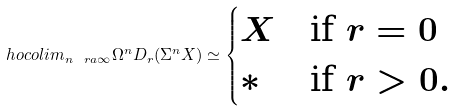Convert formula to latex. <formula><loc_0><loc_0><loc_500><loc_500>\ h o c o l i m _ { n \ r a \infty } \Omega ^ { n } D _ { r } ( \Sigma ^ { n } X ) \simeq \begin{cases} X & \text {if } r = 0 \\ * & \text {if } r > 0 . \end{cases}</formula> 